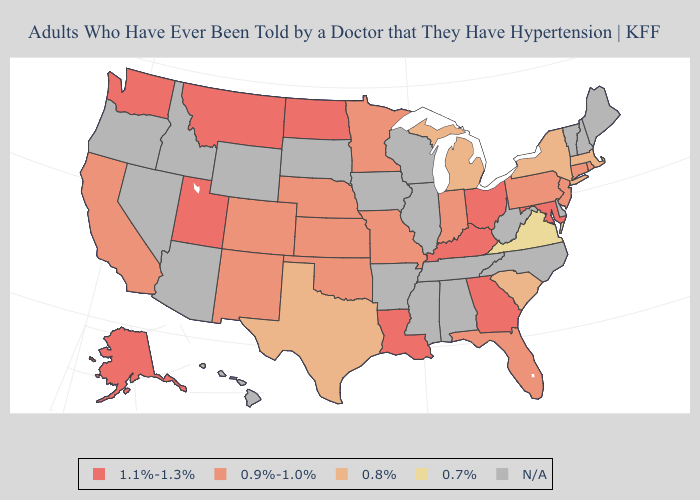Which states have the highest value in the USA?
Be succinct. Alaska, Georgia, Kentucky, Louisiana, Maryland, Montana, North Dakota, Ohio, Utah, Washington. What is the highest value in the West ?
Keep it brief. 1.1%-1.3%. Does Indiana have the lowest value in the MidWest?
Answer briefly. No. What is the value of Maryland?
Concise answer only. 1.1%-1.3%. What is the value of Mississippi?
Keep it brief. N/A. What is the value of Minnesota?
Concise answer only. 0.9%-1.0%. Does the first symbol in the legend represent the smallest category?
Answer briefly. No. Name the states that have a value in the range N/A?
Be succinct. Alabama, Arizona, Arkansas, Delaware, Hawaii, Idaho, Illinois, Iowa, Maine, Mississippi, Nevada, New Hampshire, North Carolina, Oregon, South Dakota, Tennessee, Vermont, West Virginia, Wisconsin, Wyoming. What is the lowest value in the West?
Quick response, please. 0.9%-1.0%. Among the states that border Michigan , which have the lowest value?
Be succinct. Indiana. Name the states that have a value in the range 0.7%?
Short answer required. Virginia. What is the lowest value in the South?
Keep it brief. 0.7%. 